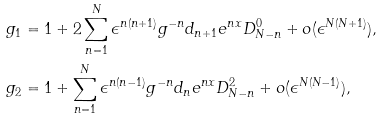Convert formula to latex. <formula><loc_0><loc_0><loc_500><loc_500>& g _ { 1 } = 1 + 2 \sum _ { n = 1 } ^ { N } \epsilon ^ { n ( n + 1 ) } g ^ { - n } d _ { n + 1 } e ^ { n x } D _ { N - n } ^ { 0 } + o ( \epsilon ^ { N ( N + 1 ) } ) , \\ & g _ { 2 } = 1 + \sum _ { n = 1 } ^ { N } \epsilon ^ { n ( n - 1 ) } g ^ { - n } d _ { n } e ^ { n x } D _ { N - n } ^ { 2 } + o ( \epsilon ^ { N ( N - 1 ) } ) ,</formula> 